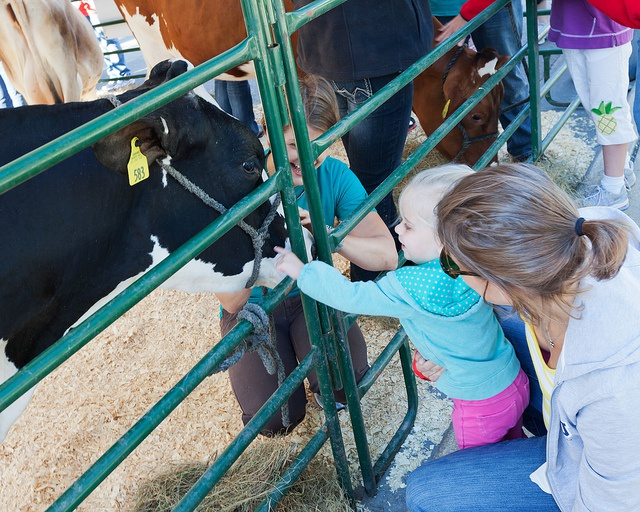Describe the objects in this image and their specific colors. I can see cow in tan, black, lightgray, teal, and gray tones, people in tan, lavender, gray, and darkgray tones, people in tan, lightblue, lightgray, and violet tones, people in tan, black, navy, gray, and blue tones, and people in tan, black, gray, and darkgray tones in this image. 